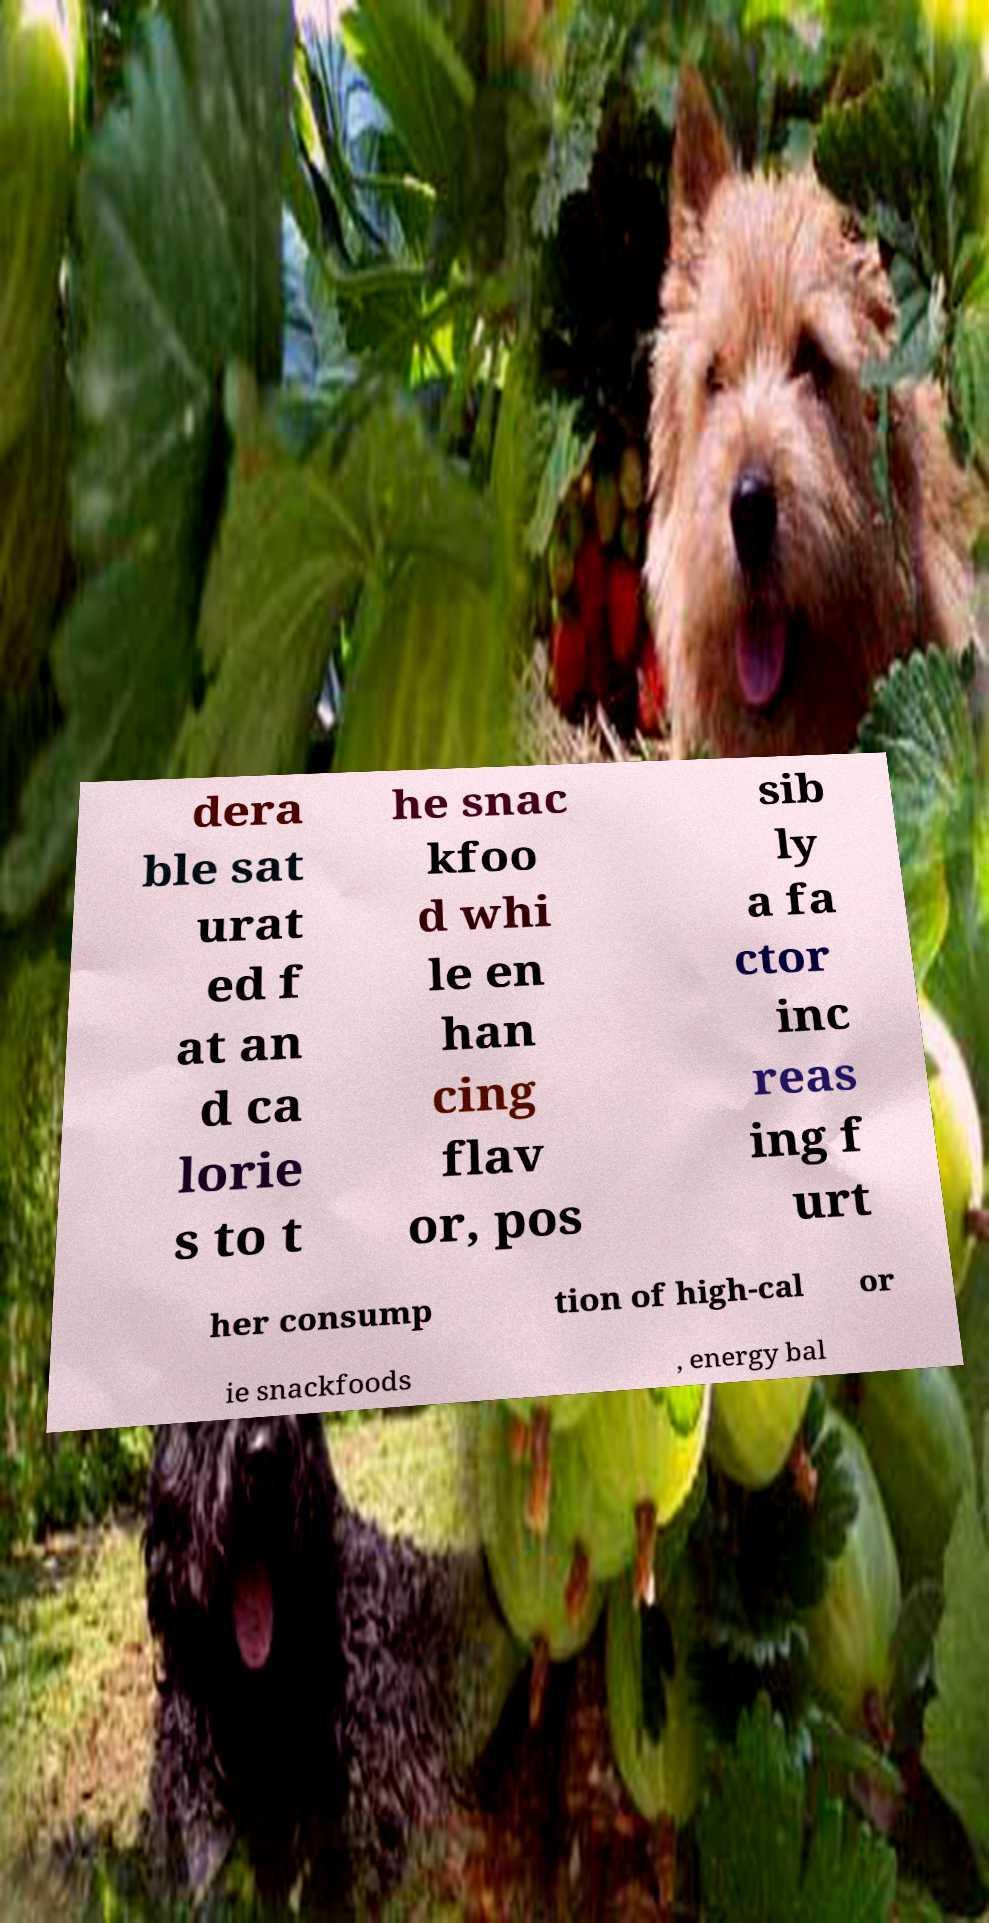Please identify and transcribe the text found in this image. dera ble sat urat ed f at an d ca lorie s to t he snac kfoo d whi le en han cing flav or, pos sib ly a fa ctor inc reas ing f urt her consump tion of high-cal or ie snackfoods , energy bal 